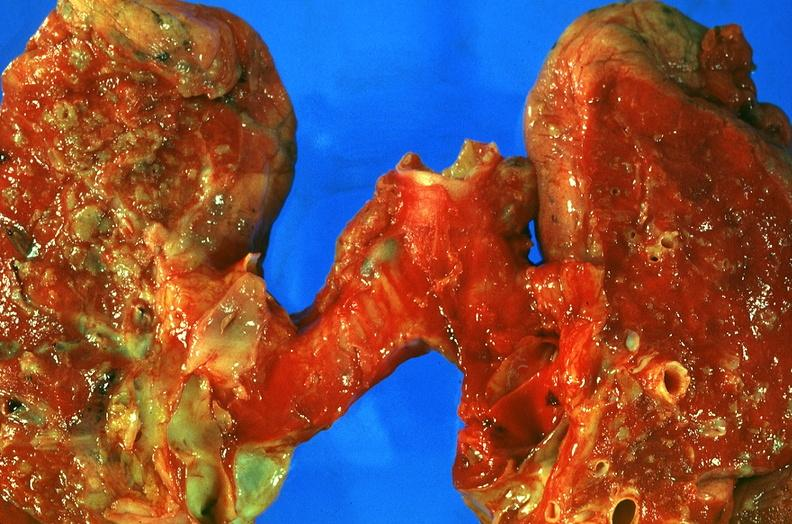where is this?
Answer the question using a single word or phrase. Lung 